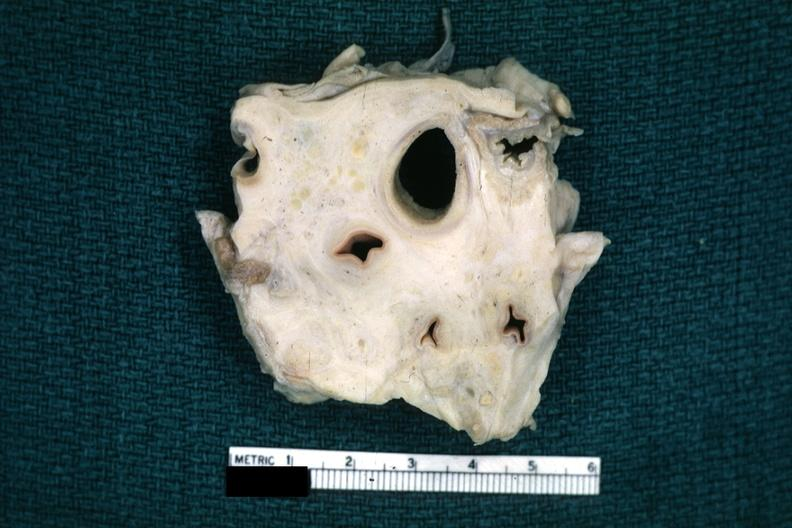how is fixed tissue trachea and arteries surrounded by dense tumor tissue section?
Answer the question using a single word or phrase. Horizontal 